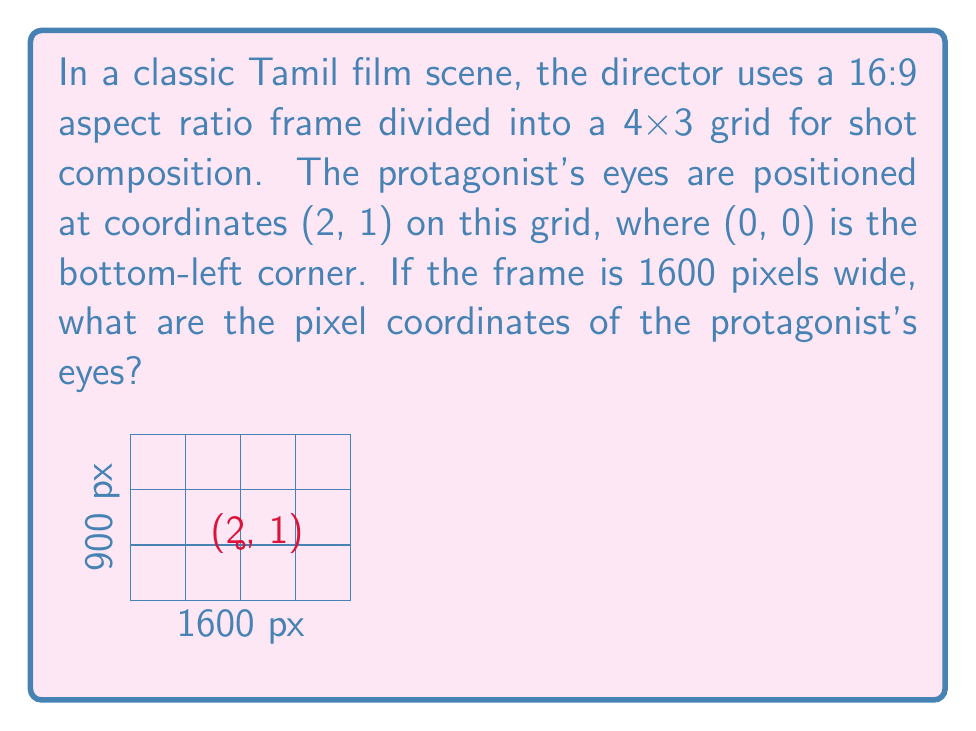Show me your answer to this math problem. Let's approach this step-by-step:

1) First, we need to determine the dimensions of the frame in pixels:
   - Width is given as 1600 pixels
   - For a 16:9 aspect ratio, height = (9/16) * width
   - Height = (9/16) * 1600 = 900 pixels

2) Now, we need to find the size of each grid cell:
   - Horizontal size: 1600 pixels / 4 = 400 pixels per cell
   - Vertical size: 900 pixels / 3 = 300 pixels per cell

3) The protagonist's eyes are at (2, 1) on the grid. To convert this to pixels:
   - X coordinate: 2 * 400 = 800 pixels from the left
   - Y coordinate: 1 * 300 = 300 pixels from the bottom

4) However, in most digital image coordinate systems, (0, 0) is at the top-left corner, and the Y-axis increases downwards. So we need to subtract the Y coordinate from the frame height:
   - Y coordinate in pixels from top: 900 - 300 = 600 pixels

Therefore, the pixel coordinates are (800, 600), where 800 is the distance from the left edge and 600 is the distance from the top edge of the frame.
Answer: (800, 600) 